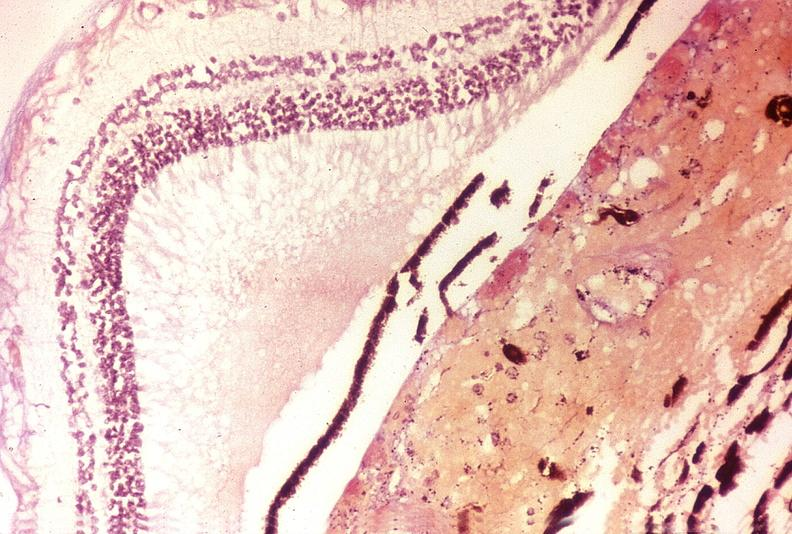s this photo of infant from head to toe present?
Answer the question using a single word or phrase. No 